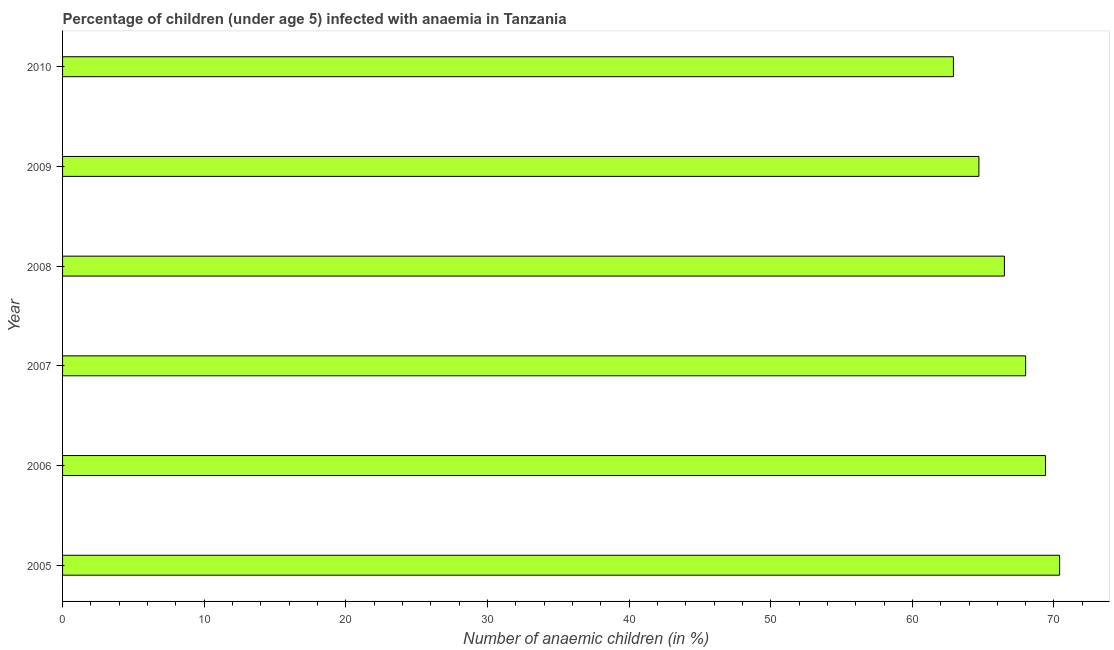What is the title of the graph?
Provide a succinct answer. Percentage of children (under age 5) infected with anaemia in Tanzania. What is the label or title of the X-axis?
Provide a succinct answer. Number of anaemic children (in %). What is the label or title of the Y-axis?
Give a very brief answer. Year. What is the number of anaemic children in 2007?
Your answer should be very brief. 68. Across all years, what is the maximum number of anaemic children?
Give a very brief answer. 70.4. Across all years, what is the minimum number of anaemic children?
Ensure brevity in your answer.  62.9. What is the sum of the number of anaemic children?
Make the answer very short. 401.9. What is the average number of anaemic children per year?
Keep it short and to the point. 66.98. What is the median number of anaemic children?
Your answer should be compact. 67.25. In how many years, is the number of anaemic children greater than 56 %?
Keep it short and to the point. 6. What is the ratio of the number of anaemic children in 2005 to that in 2010?
Give a very brief answer. 1.12. What is the difference between the highest and the lowest number of anaemic children?
Your answer should be very brief. 7.5. How many bars are there?
Offer a very short reply. 6. What is the Number of anaemic children (in %) in 2005?
Make the answer very short. 70.4. What is the Number of anaemic children (in %) of 2006?
Offer a very short reply. 69.4. What is the Number of anaemic children (in %) of 2008?
Ensure brevity in your answer.  66.5. What is the Number of anaemic children (in %) in 2009?
Provide a short and direct response. 64.7. What is the Number of anaemic children (in %) of 2010?
Make the answer very short. 62.9. What is the difference between the Number of anaemic children (in %) in 2005 and 2007?
Keep it short and to the point. 2.4. What is the difference between the Number of anaemic children (in %) in 2005 and 2009?
Your answer should be compact. 5.7. What is the difference between the Number of anaemic children (in %) in 2005 and 2010?
Offer a very short reply. 7.5. What is the difference between the Number of anaemic children (in %) in 2006 and 2007?
Provide a short and direct response. 1.4. What is the difference between the Number of anaemic children (in %) in 2006 and 2008?
Your answer should be very brief. 2.9. What is the difference between the Number of anaemic children (in %) in 2006 and 2009?
Your answer should be compact. 4.7. What is the difference between the Number of anaemic children (in %) in 2006 and 2010?
Your answer should be compact. 6.5. What is the difference between the Number of anaemic children (in %) in 2007 and 2008?
Give a very brief answer. 1.5. What is the difference between the Number of anaemic children (in %) in 2007 and 2010?
Your answer should be very brief. 5.1. What is the difference between the Number of anaemic children (in %) in 2008 and 2010?
Offer a very short reply. 3.6. What is the difference between the Number of anaemic children (in %) in 2009 and 2010?
Your answer should be compact. 1.8. What is the ratio of the Number of anaemic children (in %) in 2005 to that in 2007?
Provide a succinct answer. 1.03. What is the ratio of the Number of anaemic children (in %) in 2005 to that in 2008?
Give a very brief answer. 1.06. What is the ratio of the Number of anaemic children (in %) in 2005 to that in 2009?
Provide a succinct answer. 1.09. What is the ratio of the Number of anaemic children (in %) in 2005 to that in 2010?
Your answer should be very brief. 1.12. What is the ratio of the Number of anaemic children (in %) in 2006 to that in 2008?
Offer a very short reply. 1.04. What is the ratio of the Number of anaemic children (in %) in 2006 to that in 2009?
Keep it short and to the point. 1.07. What is the ratio of the Number of anaemic children (in %) in 2006 to that in 2010?
Offer a terse response. 1.1. What is the ratio of the Number of anaemic children (in %) in 2007 to that in 2009?
Keep it short and to the point. 1.05. What is the ratio of the Number of anaemic children (in %) in 2007 to that in 2010?
Keep it short and to the point. 1.08. What is the ratio of the Number of anaemic children (in %) in 2008 to that in 2009?
Provide a succinct answer. 1.03. What is the ratio of the Number of anaemic children (in %) in 2008 to that in 2010?
Your answer should be very brief. 1.06. 